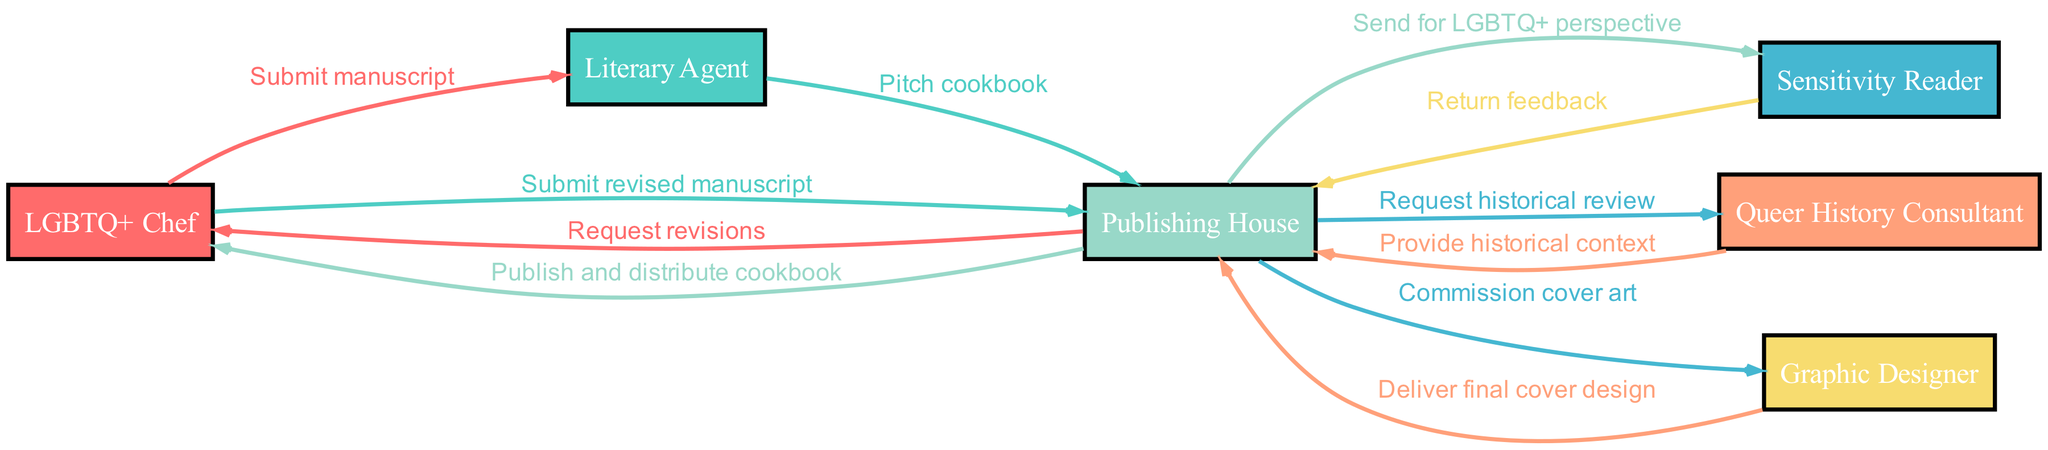What is the first action taken in the journey? The journey starts with the LGBTQ+ Chef submitting the manuscript to the Literary Agent, which is the first action depicted in the diagram.
Answer: Submit manuscript How many actors are involved in the cookbook journey? The diagram lists six distinct actors involved in the journey of the cookbook, which are the LGBTQ+ Chef, Literary Agent, Sensitivity Reader, Queer History Consultant, Publishing House, and Graphic Designer.
Answer: Six What action comes after the Publishing House requests a historical review? After the Publishing House requests a historical review, the Queer History Consultant provides the historical context, which is the subsequent action in the flow.
Answer: Provide historical context Which actor returns feedback to the Publishing House? The Sensitivity Reader is the actor responsible for returning feedback to the Publishing House, as outlined in the diagram.
Answer: Sensitivity Reader Which two actors are connected through the action "Pitch cookbook"? The Literary Agent pitches the cookbook to the Publishing House, indicating a direct relationship between these two actors through this specific action.
Answer: Literary Agent and Publishing House What is the final action in the journey of the cookbook? The final action of the journey is for the Publishing House to publish and distribute the cookbook, marking the conclusion of the series of interactions depicted in the diagram.
Answer: Publish and distribute cookbook How many feedback loops are present in the sequence? In the sequence, there is one feedback loop that occurs when the Publishing House requests revisions after receiving feedback from the Sensitivity Reader, indicating a return to the LGBTQ+ Chef for further action.
Answer: One What is the role of the Graphic Designer in this journey? The Graphic Designer's role is to deliver the final cover design to the Publishing House after being commissioned for cover art, indicating their contribution to the visual aspects of the cookbook publication.
Answer: Deliver final cover design Which action occurs immediately after the LGBTQ+ Chef submits the revised manuscript? Following the submission of the revised manuscript by the LGBTQ+ Chef, the Publishing House commissions the cover art from the Graphic Designer, marking the next step in the publication process.
Answer: Commission cover art 